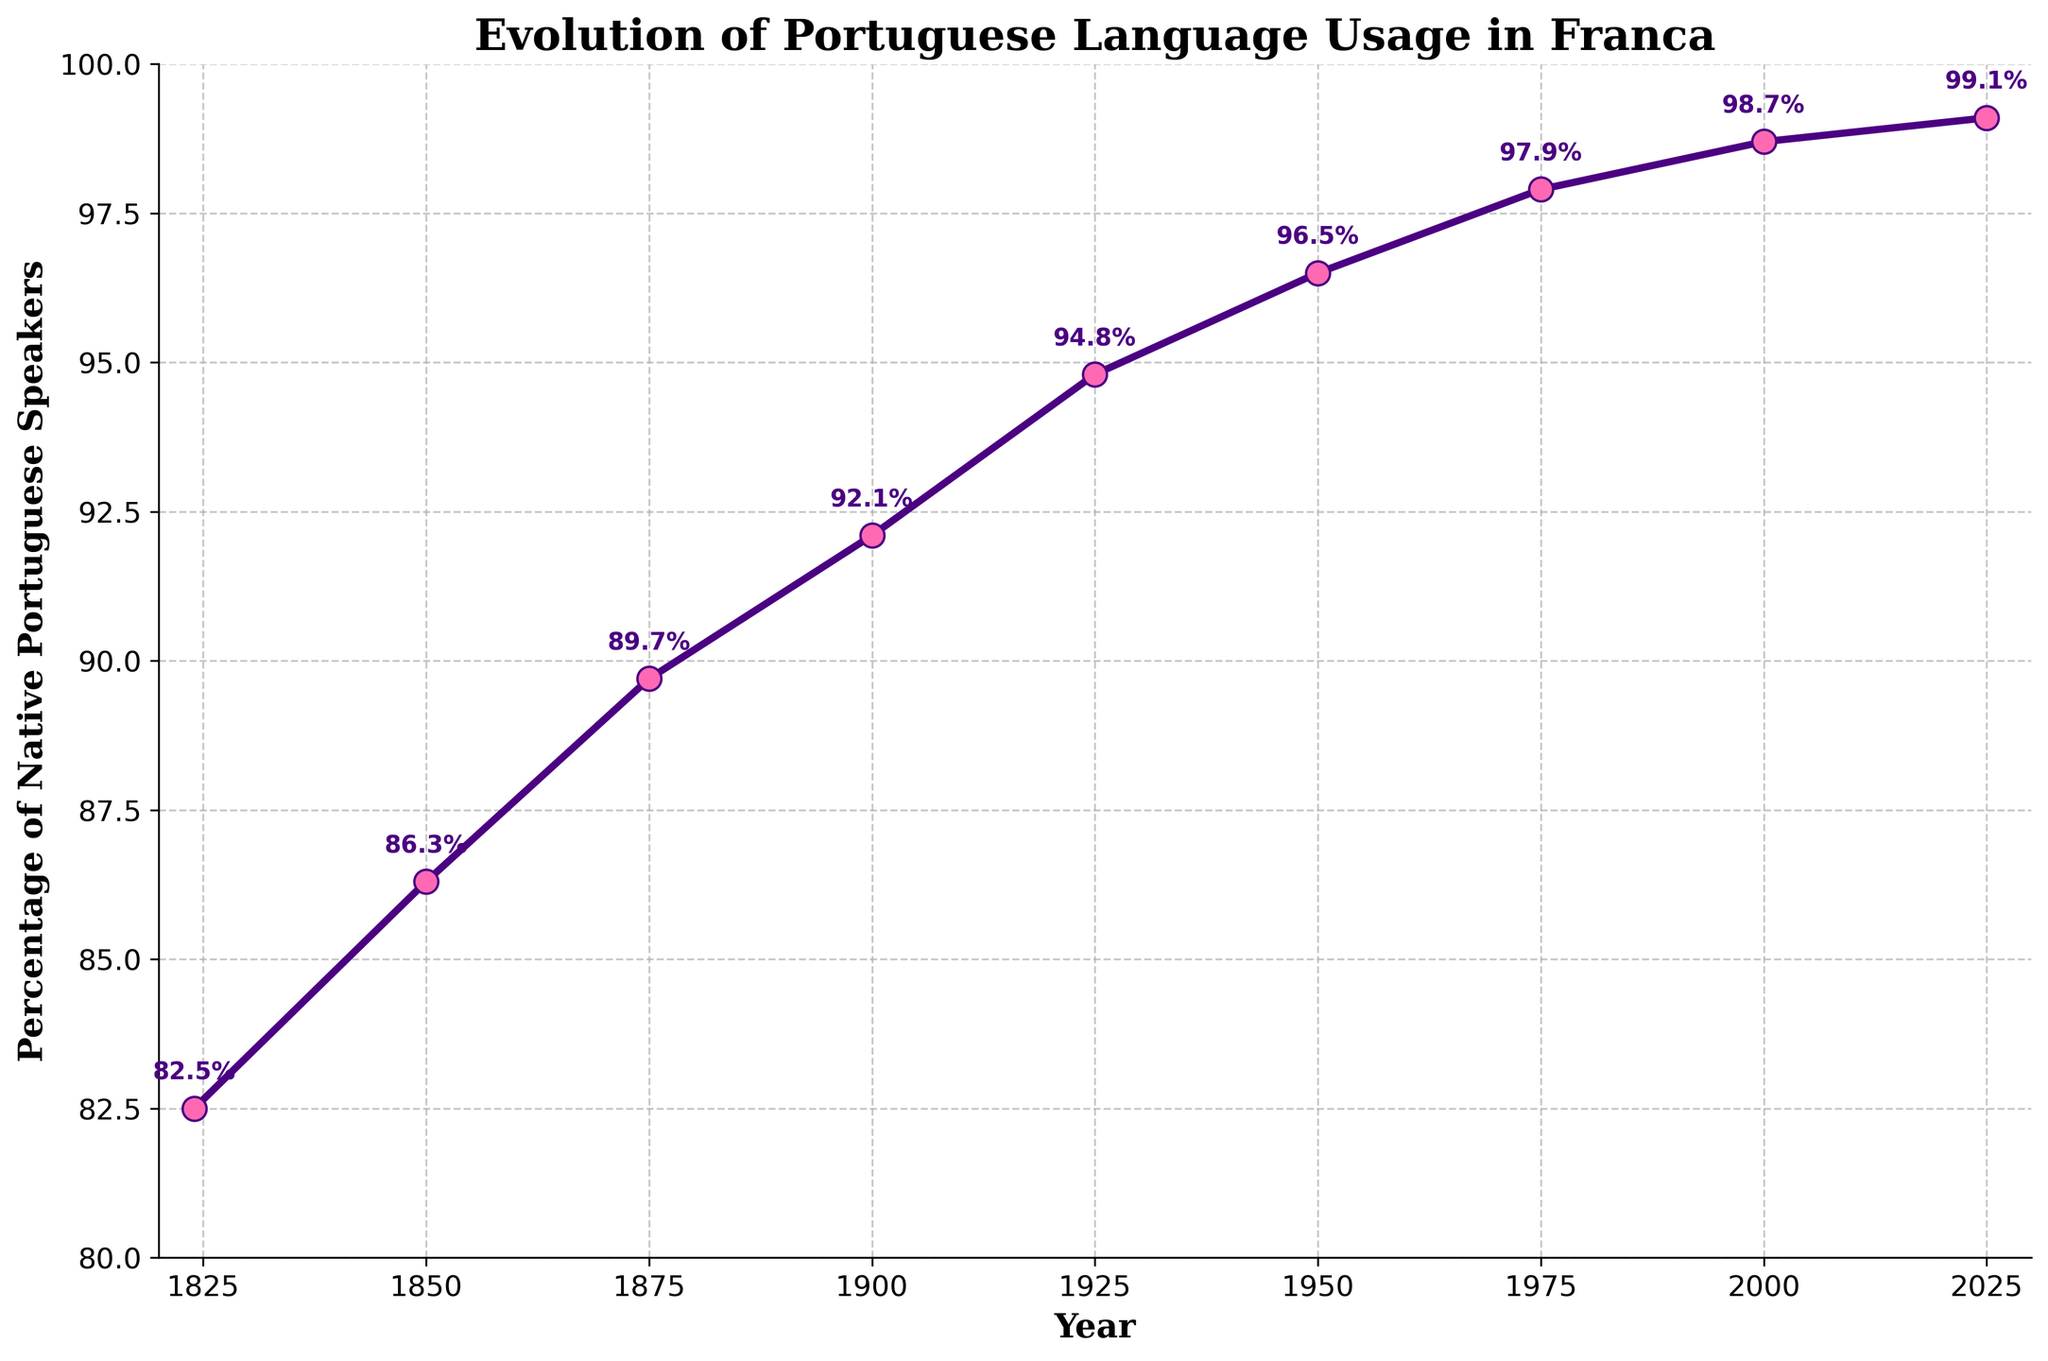What's the highest percentage of native Portuguese speakers recorded on the chart? Look at the data points on the chart, the highest percentage recorded is in 2025 with 99.1%.
Answer: 99.1% When did the percentage of native Portuguese speakers reach 96.5%? Observe the point where the percentage reaches 96.5% and it matches with the year 1950.
Answer: 1950 How does the trend of percentage of native Portuguese speakers change from 1824 to 2025? Follow the line from 1824 to 2025, it consistently rises, indicating an increasing trend over the years.
Answer: Increasing trend What is the difference in percentage of native Portuguese speakers between 1850 and 2000? Find the percentage for both years: 86.3% for 1850 and 98.7% for 2000. The difference is 98.7% - 86.3% = 12.4%.
Answer: 12.4% Which period witnessed the highest increase in percentage of native Portuguese speakers: 1824 to 1850 or 1875 to 1900? Calculate the increase for each period: 1850 - 1824 is 86.3% - 82.5% = 3.8%, and 1900 - 1875 is 92.1% - 89.7% = 2.4%. The highest increase is from 1824 to 1850.
Answer: 1824 to 1850 Between 1900 and 2000, in which decade did the percentage of native Portuguese speakers increase the most? While the chart labels are not per decade, the closest observation points show increases across a longer span than a single decade. Therefore, exact per-decade analysis is complex without further data for interpolation.
Answer: Not precisely determinable from chart What general pattern is seen in the color and style of the data points? The data points are marked by pink dots, with a purple line and grid, indicating a consistent visual style to highlight each point and the overall trend.
Answer: Pink dots, purple line and grid By how much did the percentage of native Portuguese speakers increase from 1925 to 1975? Locate the percentages in 1925 (94.8%) and 1975 (97.9%) and compute the increase: 97.9% - 94.8% = 3.1%.
Answer: 3.1% At which year does the graph show the smallest increase in the percentage of native Portuguese speakers? Review the changes year by year; the smallest increase appears between 2000 (98.7%) and 2025 (99.1%) with an increase of 0.4%.
Answer: Between 2000 and 2025 What percentage increase is observed from 1824 to 2025? Calculate the overall increase from 1824 (82.5%) to 2025 (99.1%), giving 99.1% - 82.5% = 16.6%.
Answer: 16.6% 